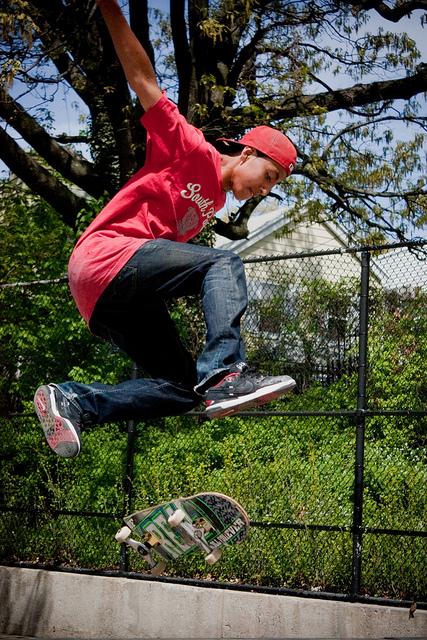What is the boy wearing backwards?
Answer briefly. Hat. What is the boy jumping on?
Keep it brief. Skateboard. What is the color of his pants?
Quick response, please. Blue. 